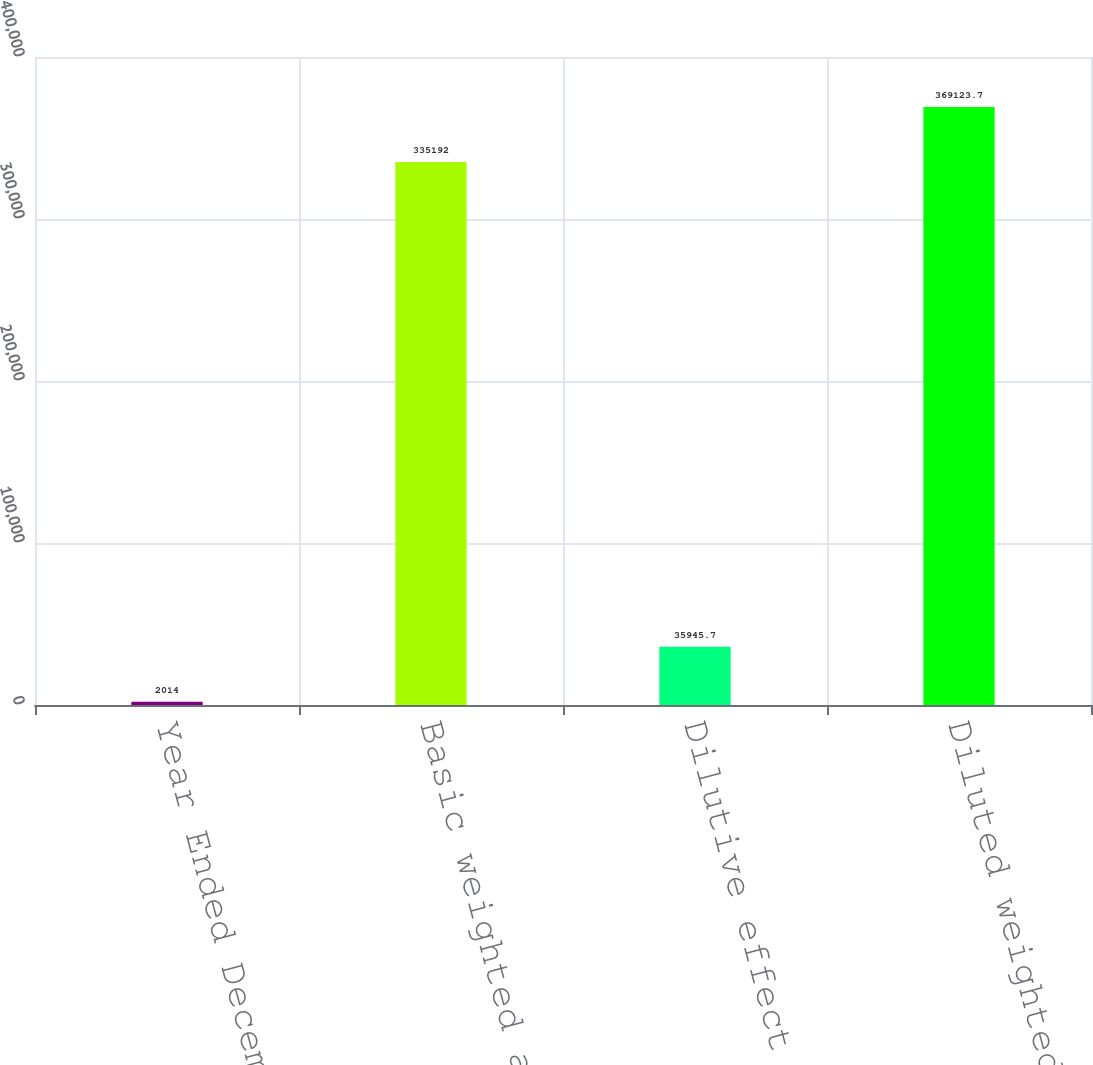Convert chart to OTSL. <chart><loc_0><loc_0><loc_500><loc_500><bar_chart><fcel>Year Ended December 31<fcel>Basic weighted average shares<fcel>Dilutive effect of stock<fcel>Diluted weighted average<nl><fcel>2014<fcel>335192<fcel>35945.7<fcel>369124<nl></chart> 